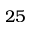Convert formula to latex. <formula><loc_0><loc_0><loc_500><loc_500>2 5</formula> 